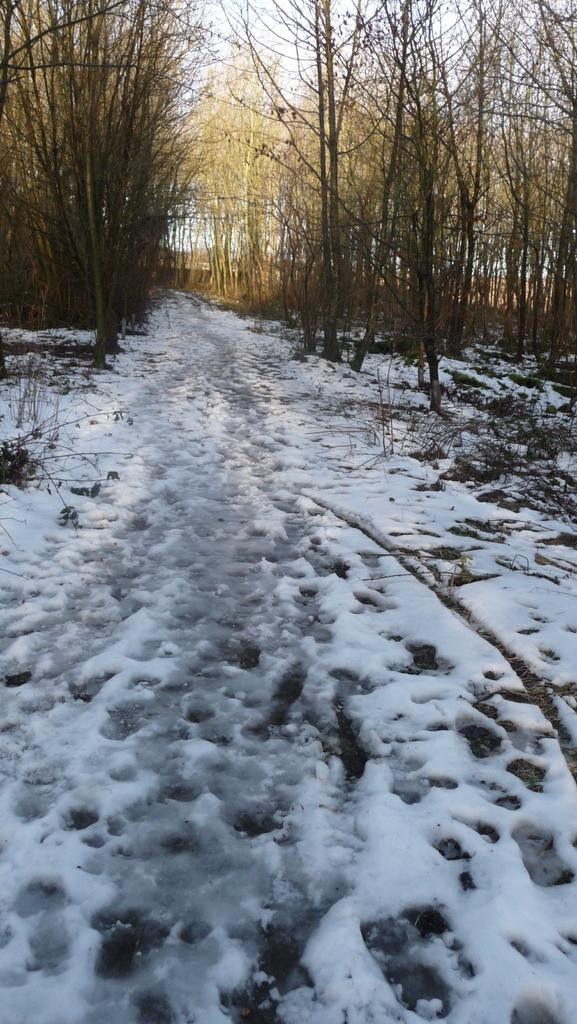What type of vegetation can be seen in the image? There are trees in the image. What is covering the surface at the bottom of the image? There is snow on the surface at the bottom of the image. What part of the natural environment is visible in the image? The sky is visible at the top of the image. What language is spoken by the airplane in the image? There is no airplane present in the image, so it is not possible to determine what language might be spoken by an airplane. What force is responsible for the snow in the image? The facts provided do not specify the cause of the snow in the image, so it is not possible to determine the force responsible for it. 